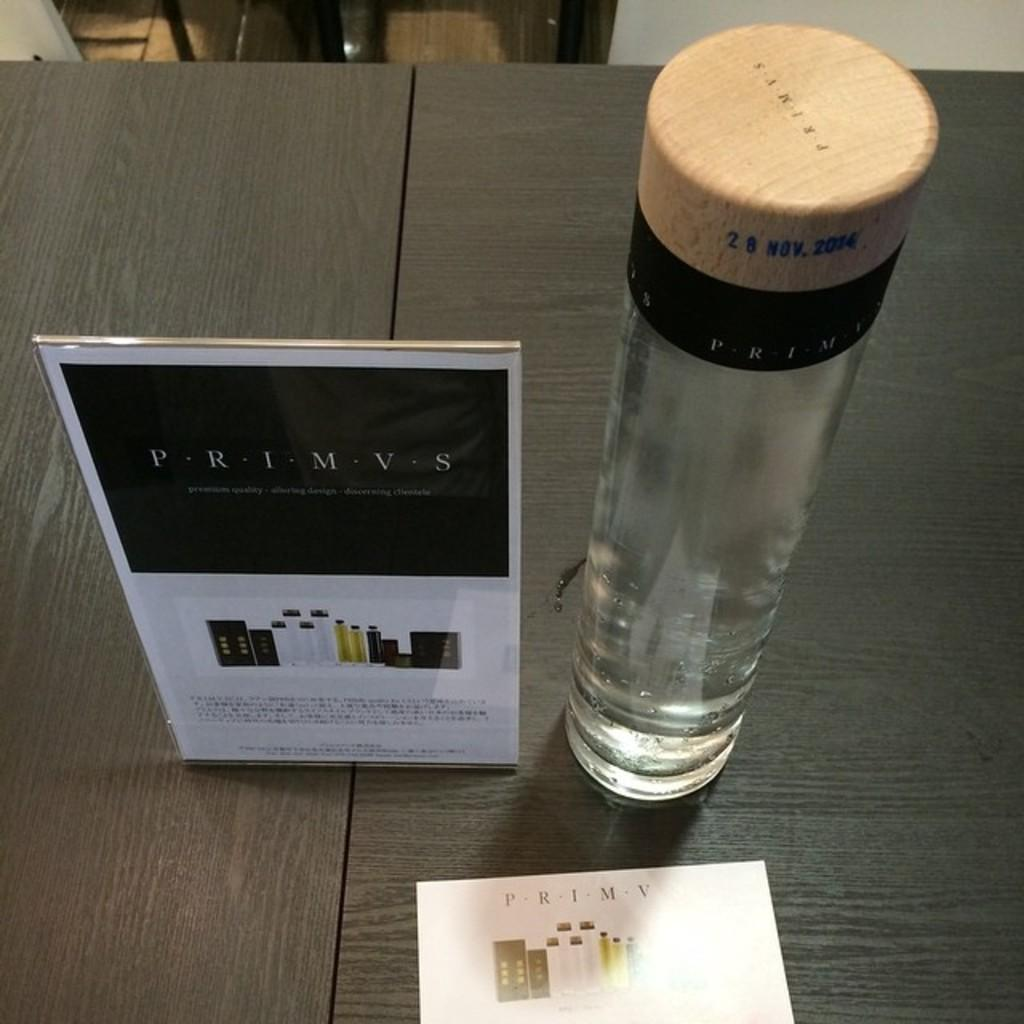<image>
Relay a brief, clear account of the picture shown. The products shown on the table are from a company called Primvs. 